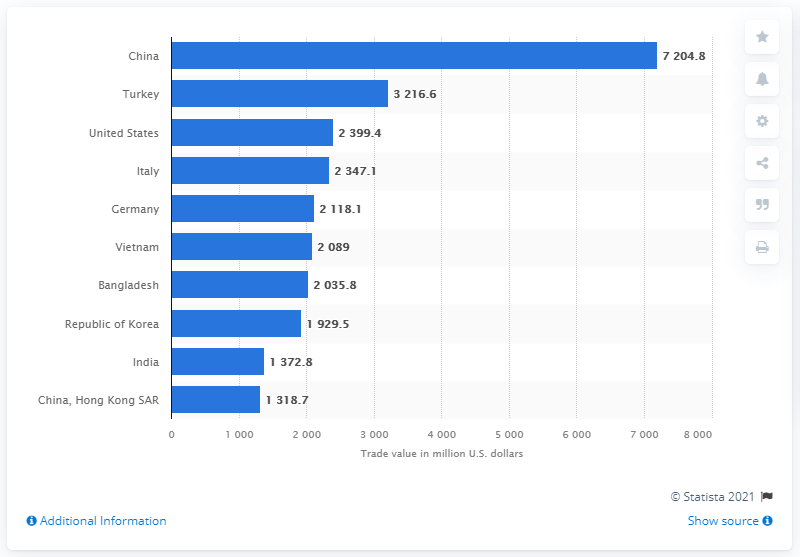Identify some key points in this picture. Turkey was the second largest importer of textile yarn in the country. In 2019, China imported a total of 7,204.8 metric tons of textile yarn from other countries. In 2019, China imported a total of 7.2 billion U.S. dollars worth of textile yarn from other countries. 